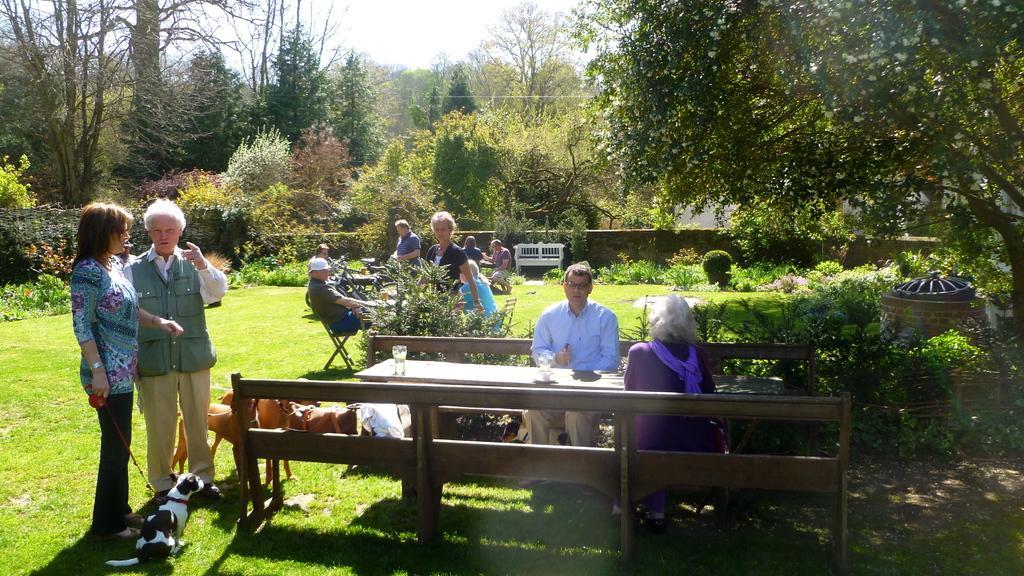Please provide a concise description of this image. People are sitting in groups at different tables in a garden with some trees and dogs around them. 